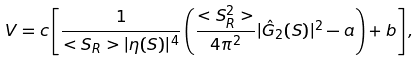Convert formula to latex. <formula><loc_0><loc_0><loc_500><loc_500>V = c \left [ \frac { 1 } { < S _ { R } > | \eta ( S ) | ^ { 4 } } \left ( \frac { < S _ { R } ^ { 2 } > } { 4 \pi ^ { 2 } } | \hat { G } _ { 2 } ( S ) | ^ { 2 } - a \right ) + b \right ] ,</formula> 